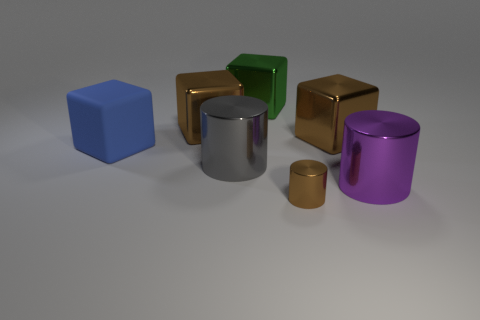Subtract all yellow blocks. Subtract all gray spheres. How many blocks are left? 4 Add 2 small shiny cylinders. How many objects exist? 9 Subtract all cylinders. How many objects are left? 4 Add 5 large blue blocks. How many large blue blocks are left? 6 Add 3 big objects. How many big objects exist? 9 Subtract 0 blue cylinders. How many objects are left? 7 Subtract all large green things. Subtract all big brown blocks. How many objects are left? 4 